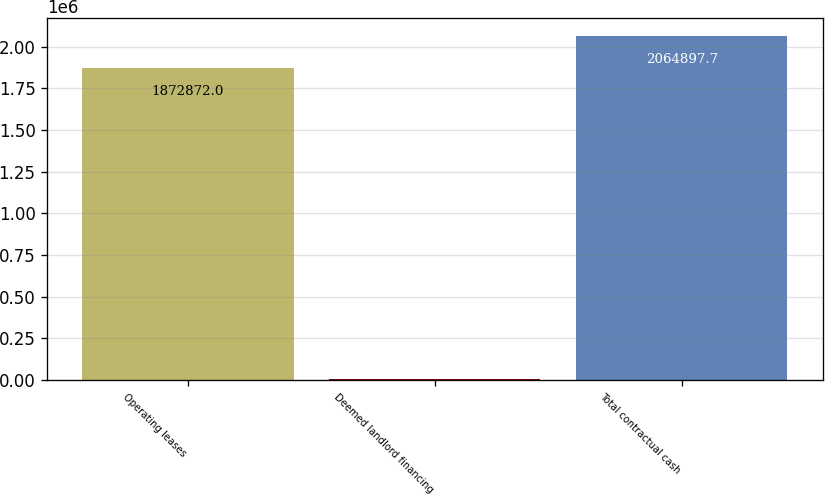<chart> <loc_0><loc_0><loc_500><loc_500><bar_chart><fcel>Operating leases<fcel>Deemed landlord financing<fcel>Total contractual cash<nl><fcel>1.87287e+06<fcel>6289<fcel>2.0649e+06<nl></chart> 